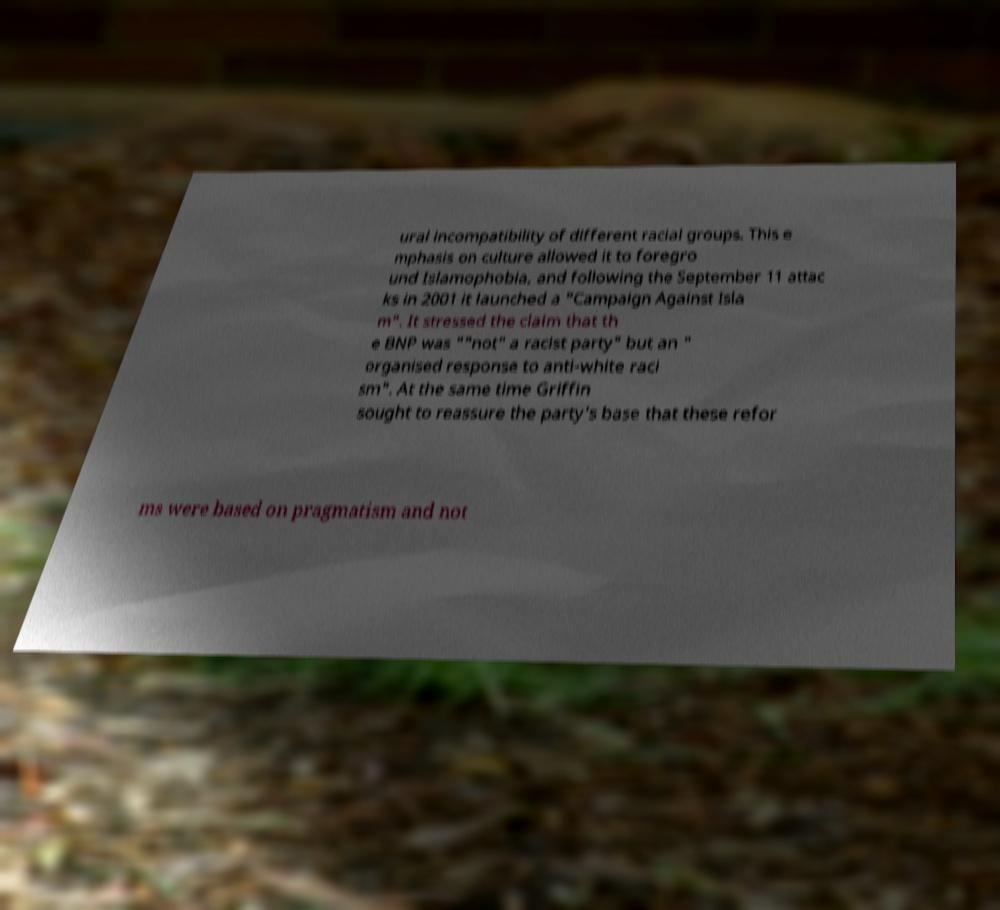Please read and relay the text visible in this image. What does it say? ural incompatibility of different racial groups. This e mphasis on culture allowed it to foregro und Islamophobia, and following the September 11 attac ks in 2001 it launched a "Campaign Against Isla m". It stressed the claim that th e BNP was ""not" a racist party" but an " organised response to anti-white raci sm". At the same time Griffin sought to reassure the party's base that these refor ms were based on pragmatism and not 